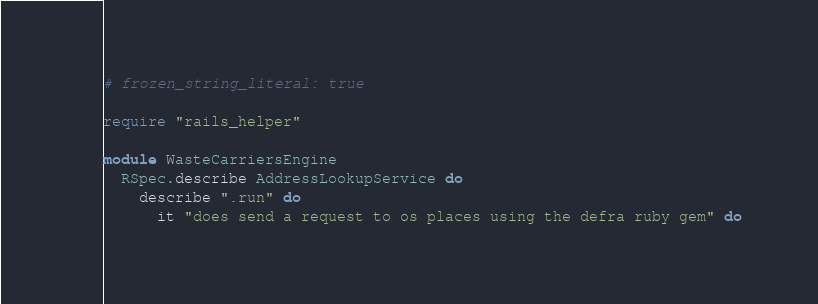Convert code to text. <code><loc_0><loc_0><loc_500><loc_500><_Ruby_># frozen_string_literal: true

require "rails_helper"

module WasteCarriersEngine
  RSpec.describe AddressLookupService do
    describe ".run" do
      it "does send a request to os places using the defra ruby gem" do</code> 